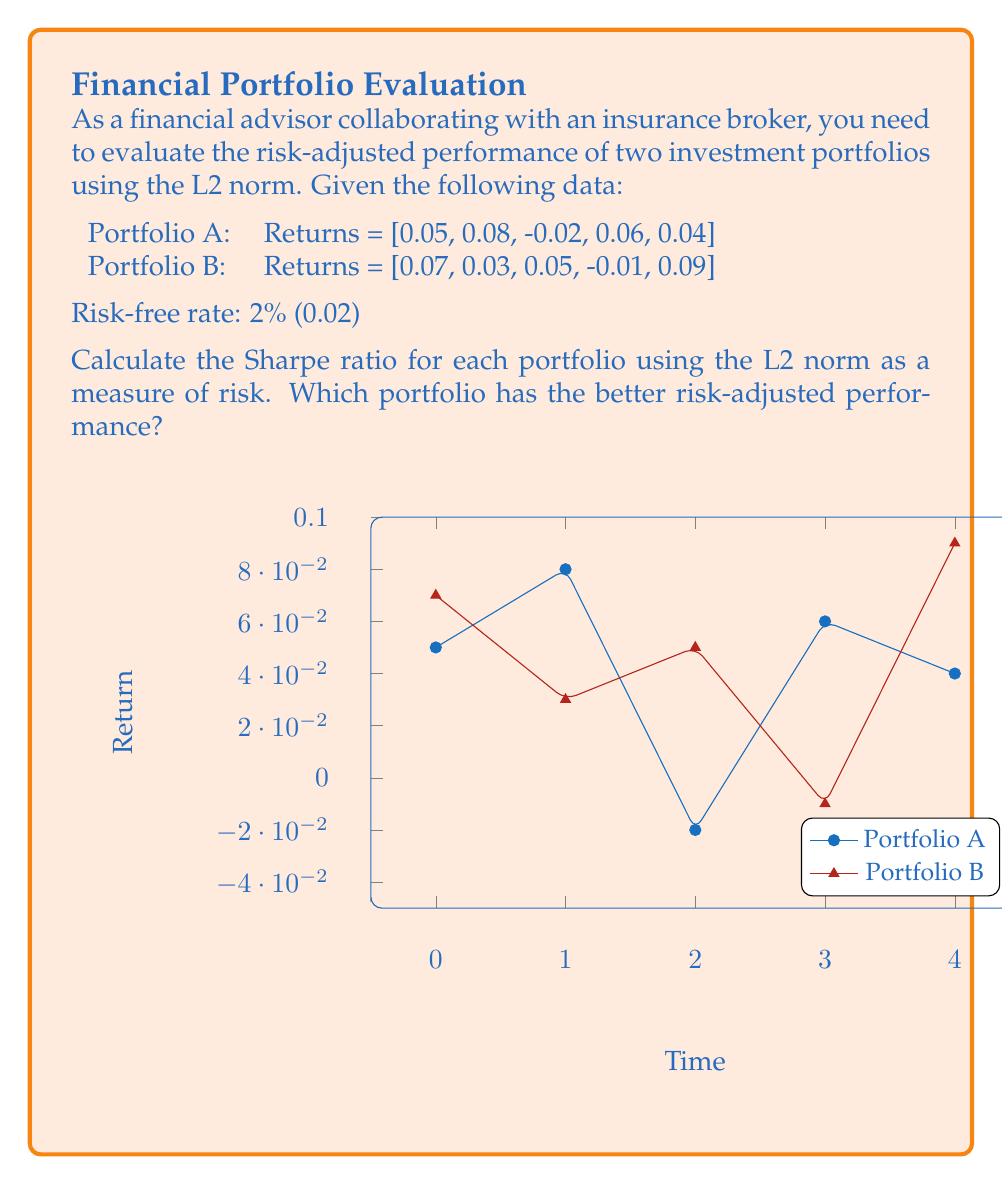Could you help me with this problem? To evaluate the risk-adjusted performance of the portfolios using the L2 norm, we'll calculate the Sharpe ratio for each portfolio. The Sharpe ratio is defined as:

$$ \text{Sharpe Ratio} = \frac{\text{Portfolio Return} - \text{Risk-free Rate}}{\text{Portfolio Risk}} $$

Where the portfolio risk is measured using the L2 norm.

Step 1: Calculate the average return for each portfolio.
Portfolio A: $\bar{R}_A = \frac{0.05 + 0.08 - 0.02 + 0.06 + 0.04}{5} = 0.042$
Portfolio B: $\bar{R}_B = \frac{0.07 + 0.03 + 0.05 - 0.01 + 0.09}{5} = 0.046$

Step 2: Calculate the risk (L2 norm) for each portfolio.
The L2 norm is defined as: $\|x\|_2 = \sqrt{\sum_{i=1}^n |x_i|^2}$

Portfolio A: 
$\|R_A\|_2 = \sqrt{0.05^2 + 0.08^2 + (-0.02)^2 + 0.06^2 + 0.04^2} = 0.1249$

Portfolio B:
$\|R_B\|_2 = \sqrt{0.07^2 + 0.03^2 + 0.05^2 + (-0.01)^2 + 0.09^2} = 0.1296$

Step 3: Calculate the Sharpe ratio for each portfolio.
Portfolio A:
$\text{Sharpe}_A = \frac{0.042 - 0.02}{0.1249} = 0.1762$

Portfolio B:
$\text{Sharpe}_B = \frac{0.046 - 0.02}{0.1296} = 0.2006$

Step 4: Compare the Sharpe ratios.
Portfolio B has a higher Sharpe ratio (0.2006) compared to Portfolio A (0.1762), indicating better risk-adjusted performance.
Answer: Portfolio B has better risk-adjusted performance with a Sharpe ratio of 0.2006 versus 0.1762 for Portfolio A. 